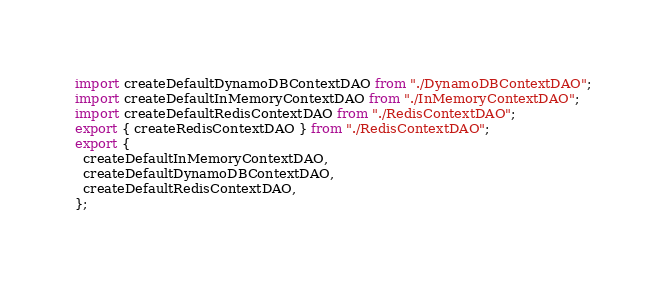<code> <loc_0><loc_0><loc_500><loc_500><_TypeScript_>import createDefaultDynamoDBContextDAO from "./DynamoDBContextDAO";
import createDefaultInMemoryContextDAO from "./InMemoryContextDAO";
import createDefaultRedisContextDAO from "./RedisContextDAO";
export { createRedisContextDAO } from "./RedisContextDAO";
export {
  createDefaultInMemoryContextDAO,
  createDefaultDynamoDBContextDAO,
  createDefaultRedisContextDAO,
};
</code> 